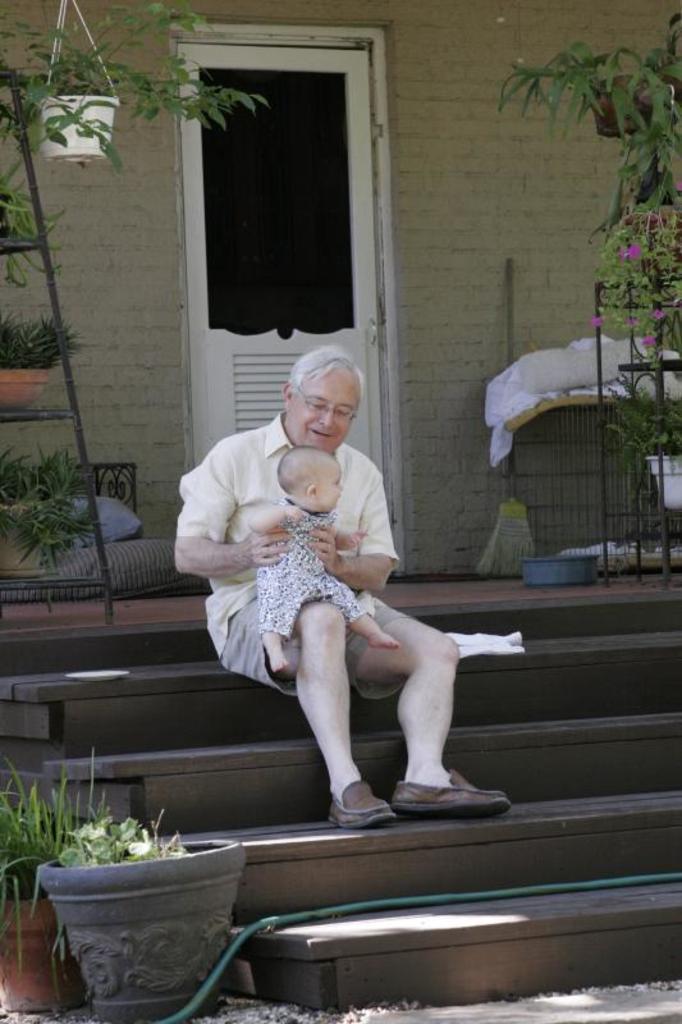How would you summarize this image in a sentence or two? In this image I can see few flower pots with plants in them , few flowers which are pink in color, few stairs and on the stairs I can see a person wearing cream colored dress is sitting and holding a baby. In the background I can see a house, a white colored door, few pillows and few other objects. 